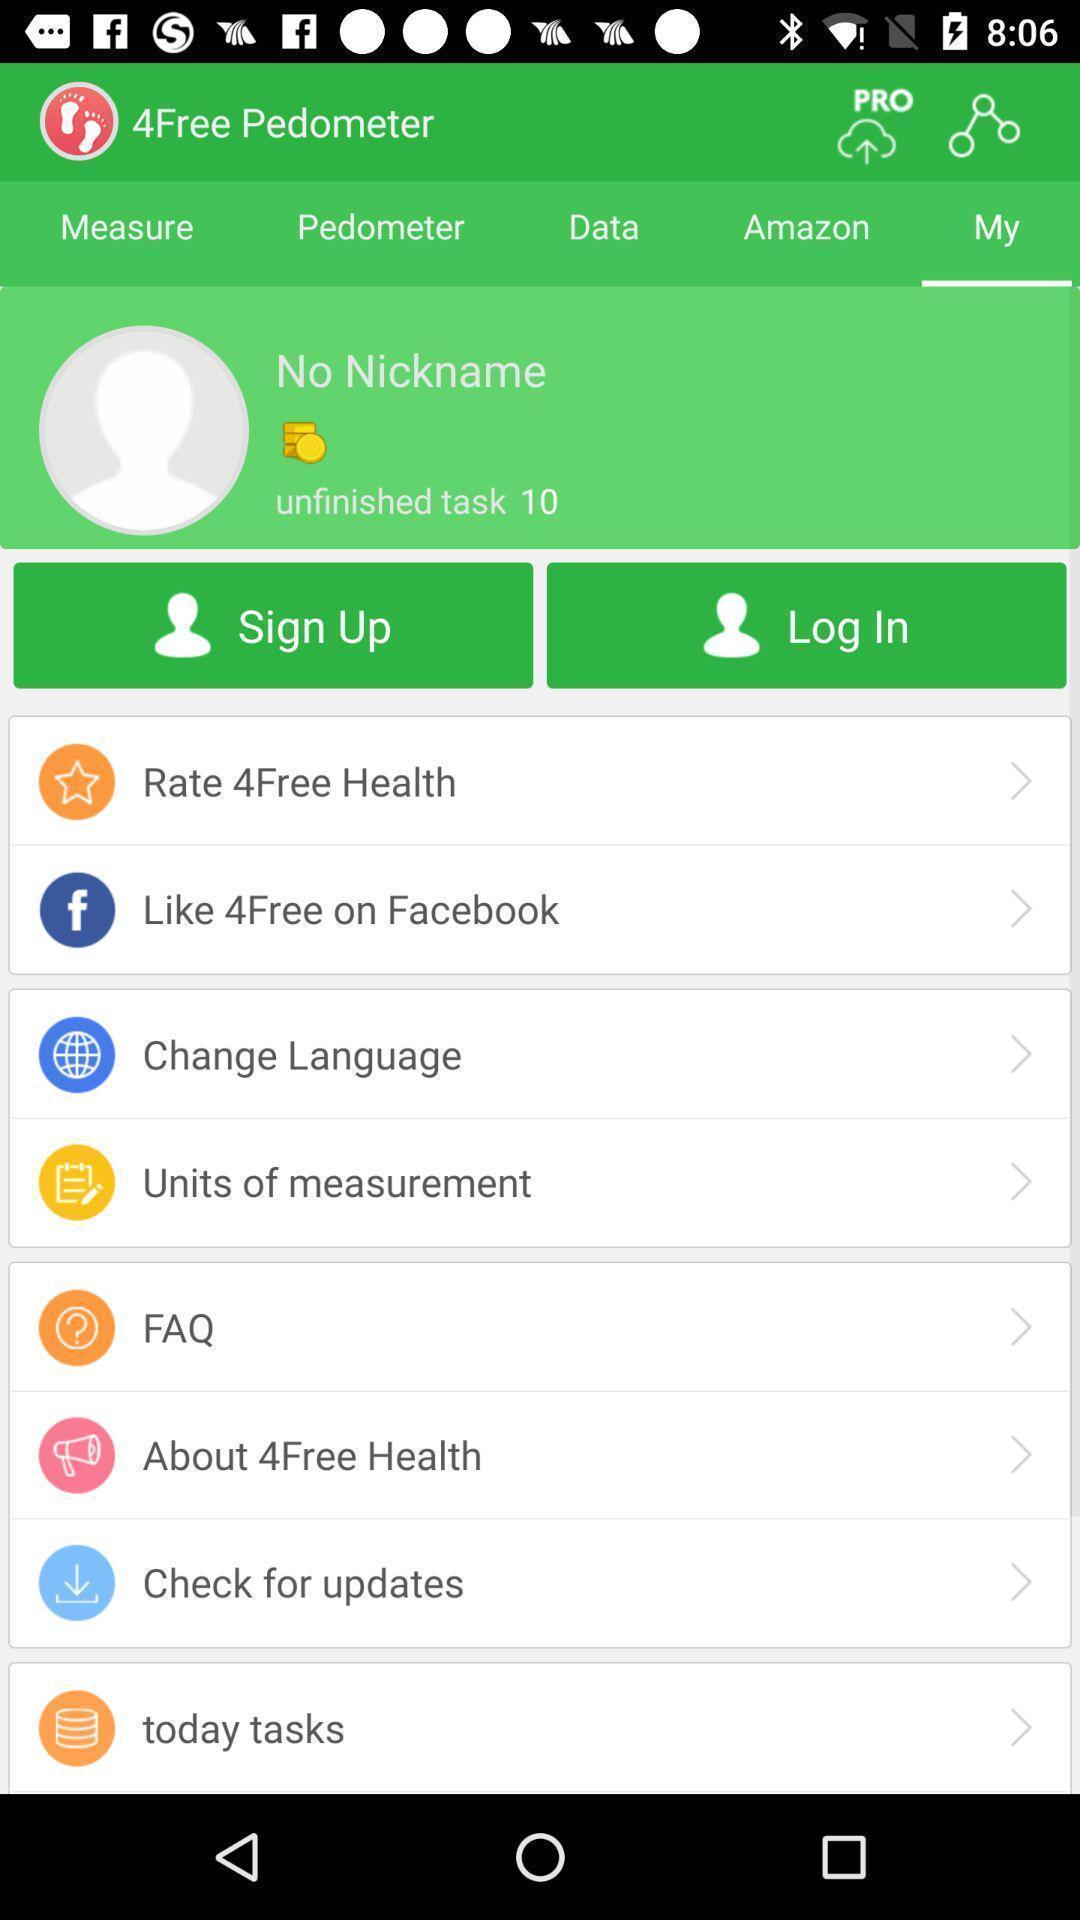Give me a narrative description of this picture. Sign in or login page. 